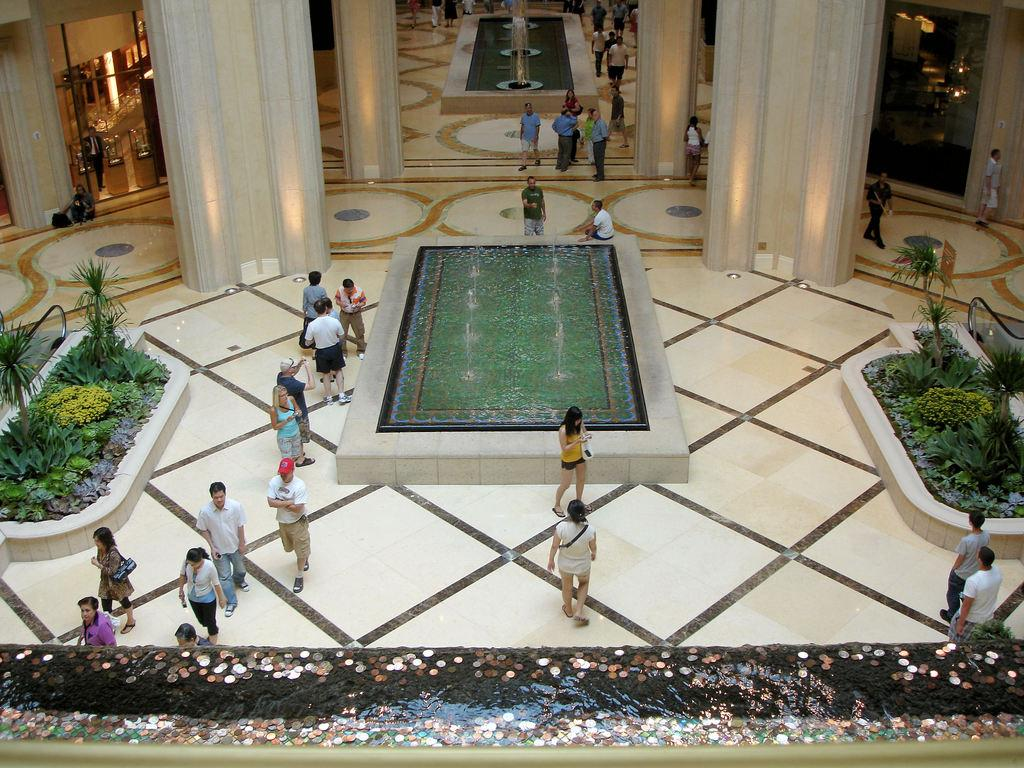What can be found at the bottom side of the image? There is a decoration at the bottom side of the image. What type of architectural feature is present in the image? There are fountains, pillars, and a door in the image. What can be seen in the image that is related to nature? There are plants in the image. Are there any people present in the image? Yes, there are people in the image. What is the source of illumination in the image? There is light in the image. Can you see the ocean in the image? No, there is no ocean present in the image. Is there a hole in the image? No, there is no hole present in the image. 